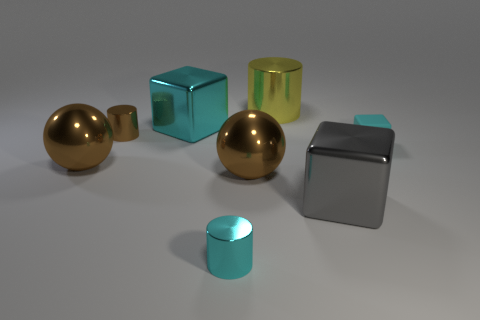Imagine these objects are part of a puzzle, what could be a rule to solve it? If these objects were part of a puzzle, a possible rule could be to align them by shape or color gradients. For instance, rearrange the objects so that the spherical ones are on one side, the cubes on another, and cylinders on another, or sequence them from lightest to darkest shades. 